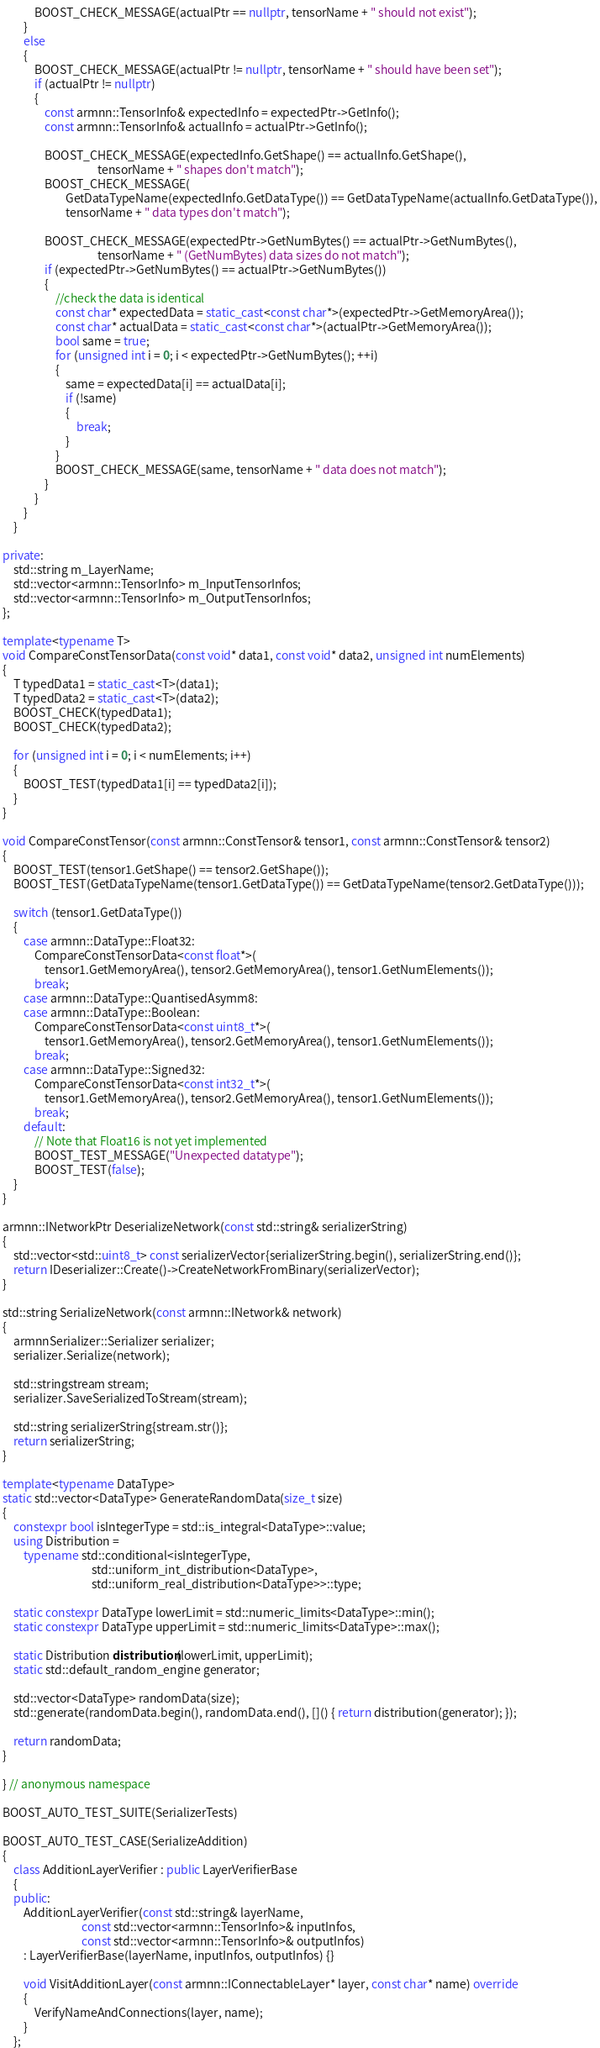<code> <loc_0><loc_0><loc_500><loc_500><_C++_>            BOOST_CHECK_MESSAGE(actualPtr == nullptr, tensorName + " should not exist");
        }
        else
        {
            BOOST_CHECK_MESSAGE(actualPtr != nullptr, tensorName + " should have been set");
            if (actualPtr != nullptr)
            {
                const armnn::TensorInfo& expectedInfo = expectedPtr->GetInfo();
                const armnn::TensorInfo& actualInfo = actualPtr->GetInfo();

                BOOST_CHECK_MESSAGE(expectedInfo.GetShape() == actualInfo.GetShape(),
                                    tensorName + " shapes don't match");
                BOOST_CHECK_MESSAGE(
                        GetDataTypeName(expectedInfo.GetDataType()) == GetDataTypeName(actualInfo.GetDataType()),
                        tensorName + " data types don't match");

                BOOST_CHECK_MESSAGE(expectedPtr->GetNumBytes() == actualPtr->GetNumBytes(),
                                    tensorName + " (GetNumBytes) data sizes do not match");
                if (expectedPtr->GetNumBytes() == actualPtr->GetNumBytes())
                {
                    //check the data is identical
                    const char* expectedData = static_cast<const char*>(expectedPtr->GetMemoryArea());
                    const char* actualData = static_cast<const char*>(actualPtr->GetMemoryArea());
                    bool same = true;
                    for (unsigned int i = 0; i < expectedPtr->GetNumBytes(); ++i)
                    {
                        same = expectedData[i] == actualData[i];
                        if (!same)
                        {
                            break;
                        }
                    }
                    BOOST_CHECK_MESSAGE(same, tensorName + " data does not match");
                }
            }
        }
    }

private:
    std::string m_LayerName;
    std::vector<armnn::TensorInfo> m_InputTensorInfos;
    std::vector<armnn::TensorInfo> m_OutputTensorInfos;
};

template<typename T>
void CompareConstTensorData(const void* data1, const void* data2, unsigned int numElements)
{
    T typedData1 = static_cast<T>(data1);
    T typedData2 = static_cast<T>(data2);
    BOOST_CHECK(typedData1);
    BOOST_CHECK(typedData2);

    for (unsigned int i = 0; i < numElements; i++)
    {
        BOOST_TEST(typedData1[i] == typedData2[i]);
    }
}

void CompareConstTensor(const armnn::ConstTensor& tensor1, const armnn::ConstTensor& tensor2)
{
    BOOST_TEST(tensor1.GetShape() == tensor2.GetShape());
    BOOST_TEST(GetDataTypeName(tensor1.GetDataType()) == GetDataTypeName(tensor2.GetDataType()));

    switch (tensor1.GetDataType())
    {
        case armnn::DataType::Float32:
            CompareConstTensorData<const float*>(
                tensor1.GetMemoryArea(), tensor2.GetMemoryArea(), tensor1.GetNumElements());
            break;
        case armnn::DataType::QuantisedAsymm8:
        case armnn::DataType::Boolean:
            CompareConstTensorData<const uint8_t*>(
                tensor1.GetMemoryArea(), tensor2.GetMemoryArea(), tensor1.GetNumElements());
            break;
        case armnn::DataType::Signed32:
            CompareConstTensorData<const int32_t*>(
                tensor1.GetMemoryArea(), tensor2.GetMemoryArea(), tensor1.GetNumElements());
            break;
        default:
            // Note that Float16 is not yet implemented
            BOOST_TEST_MESSAGE("Unexpected datatype");
            BOOST_TEST(false);
    }
}

armnn::INetworkPtr DeserializeNetwork(const std::string& serializerString)
{
    std::vector<std::uint8_t> const serializerVector{serializerString.begin(), serializerString.end()};
    return IDeserializer::Create()->CreateNetworkFromBinary(serializerVector);
}

std::string SerializeNetwork(const armnn::INetwork& network)
{
    armnnSerializer::Serializer serializer;
    serializer.Serialize(network);

    std::stringstream stream;
    serializer.SaveSerializedToStream(stream);

    std::string serializerString{stream.str()};
    return serializerString;
}

template<typename DataType>
static std::vector<DataType> GenerateRandomData(size_t size)
{
    constexpr bool isIntegerType = std::is_integral<DataType>::value;
    using Distribution =
        typename std::conditional<isIntegerType,
                                  std::uniform_int_distribution<DataType>,
                                  std::uniform_real_distribution<DataType>>::type;

    static constexpr DataType lowerLimit = std::numeric_limits<DataType>::min();
    static constexpr DataType upperLimit = std::numeric_limits<DataType>::max();

    static Distribution distribution(lowerLimit, upperLimit);
    static std::default_random_engine generator;

    std::vector<DataType> randomData(size);
    std::generate(randomData.begin(), randomData.end(), []() { return distribution(generator); });

    return randomData;
}

} // anonymous namespace

BOOST_AUTO_TEST_SUITE(SerializerTests)

BOOST_AUTO_TEST_CASE(SerializeAddition)
{
    class AdditionLayerVerifier : public LayerVerifierBase
    {
    public:
        AdditionLayerVerifier(const std::string& layerName,
                              const std::vector<armnn::TensorInfo>& inputInfos,
                              const std::vector<armnn::TensorInfo>& outputInfos)
        : LayerVerifierBase(layerName, inputInfos, outputInfos) {}

        void VisitAdditionLayer(const armnn::IConnectableLayer* layer, const char* name) override
        {
            VerifyNameAndConnections(layer, name);
        }
    };
</code> 